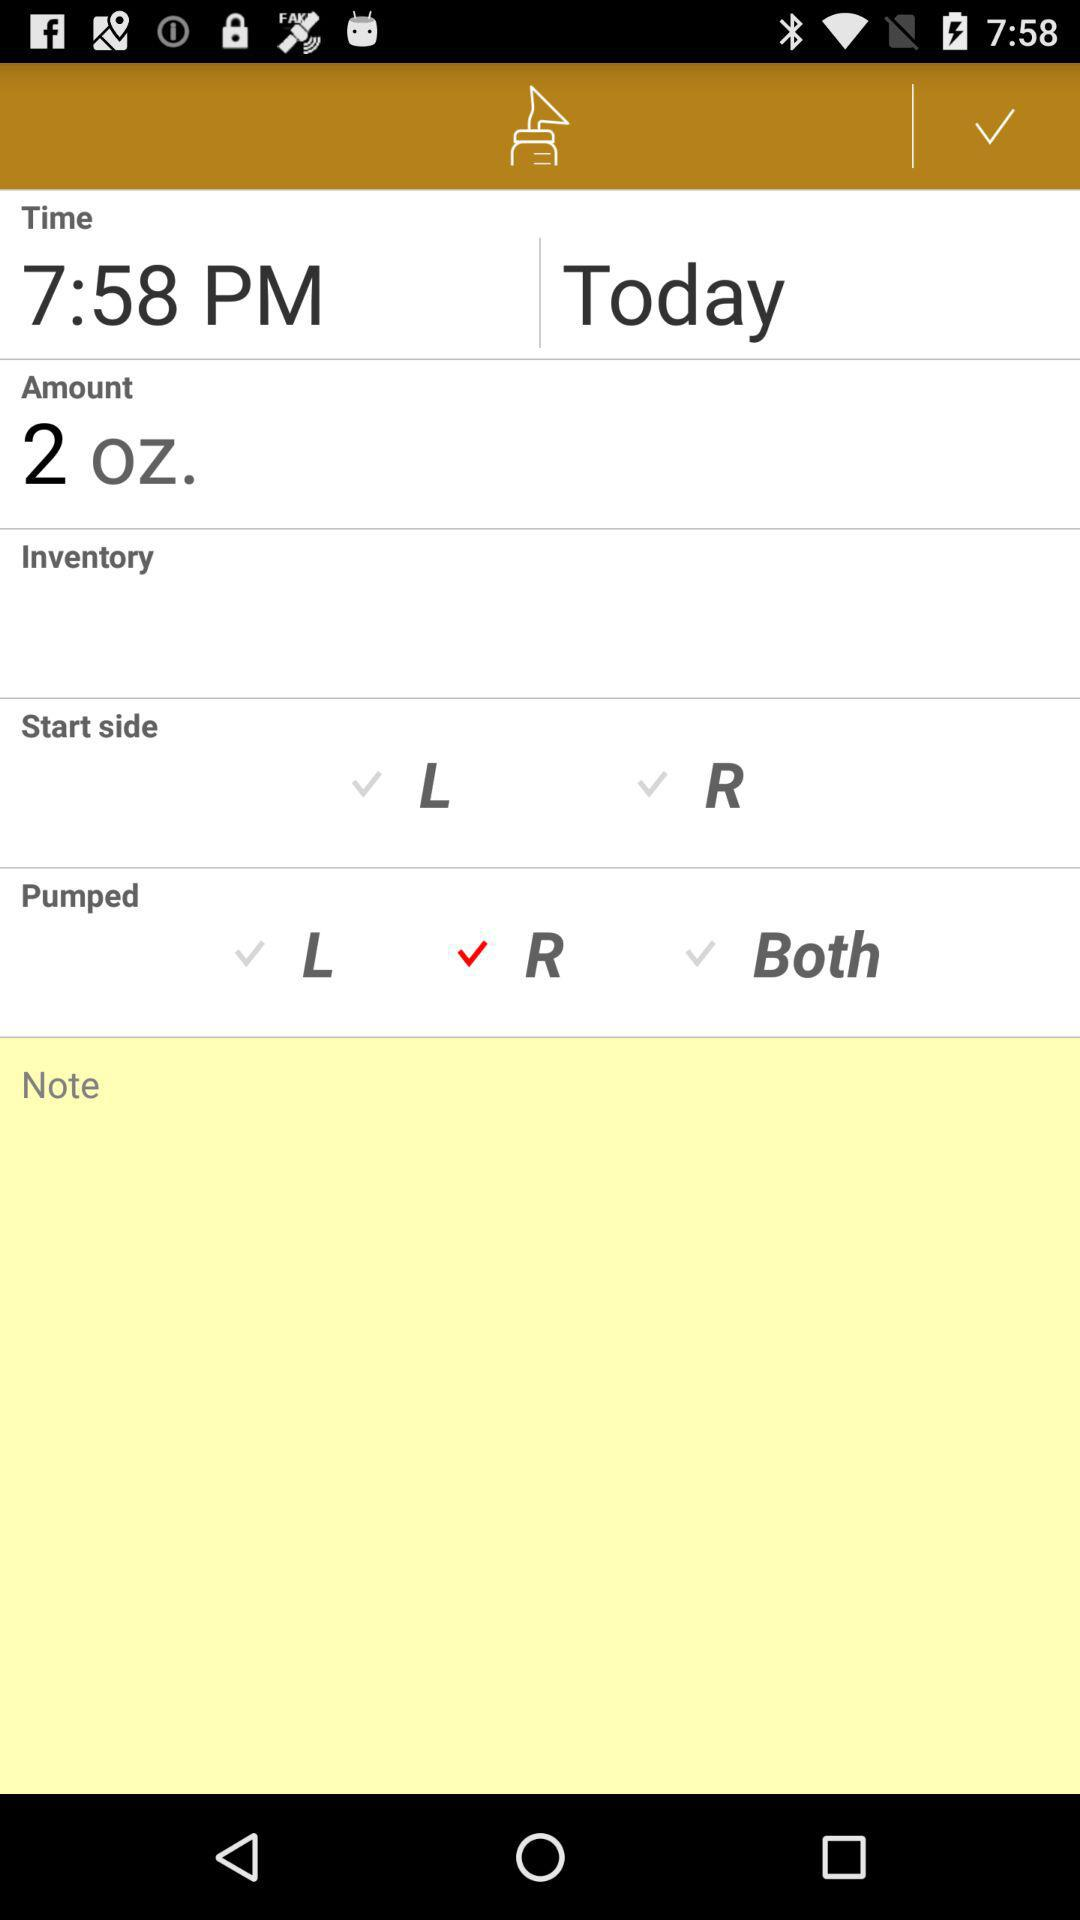Which option has been selected in "Pumped"? The selected option in "Pumped" is "R". 